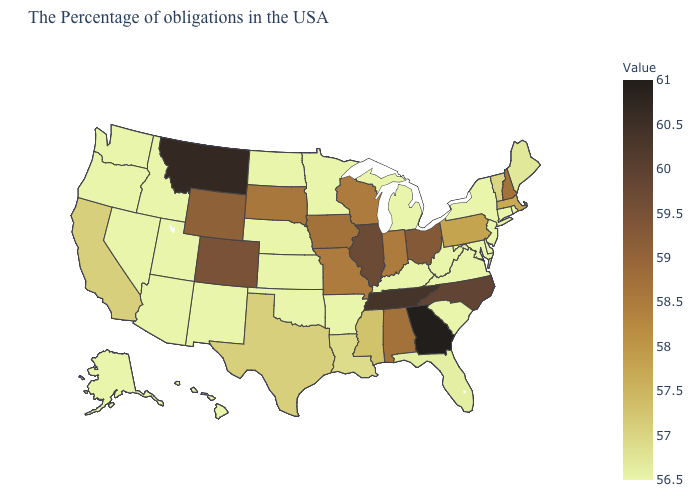Among the states that border Texas , does Louisiana have the lowest value?
Concise answer only. No. Which states have the highest value in the USA?
Answer briefly. Georgia. Which states have the lowest value in the USA?
Quick response, please. Rhode Island, Connecticut, New York, New Jersey, Delaware, Maryland, Virginia, South Carolina, West Virginia, Michigan, Kentucky, Arkansas, Minnesota, Kansas, Nebraska, Oklahoma, North Dakota, New Mexico, Utah, Arizona, Idaho, Nevada, Washington, Oregon, Alaska, Hawaii. Among the states that border Nevada , does California have the highest value?
Quick response, please. Yes. Does Pennsylvania have the highest value in the Northeast?
Give a very brief answer. No. Does Virginia have the highest value in the South?
Keep it brief. No. 